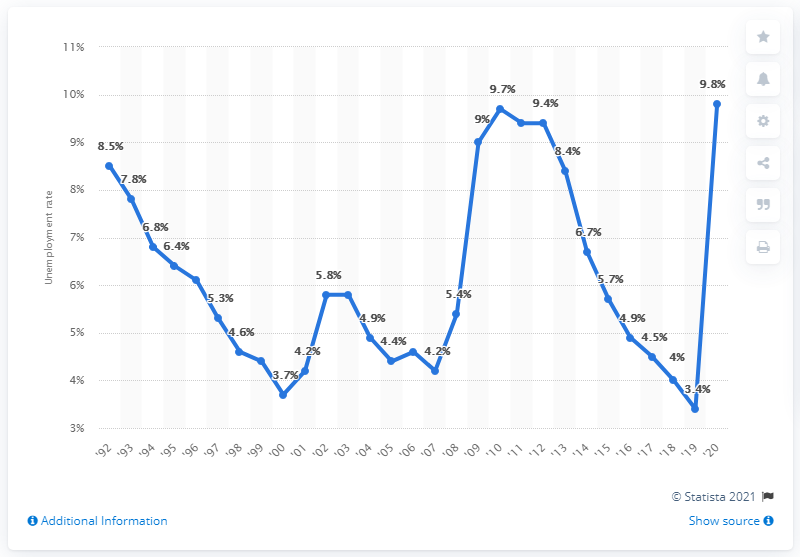Highlight a few significant elements in this photo. According to the previous year's data, the unemployment rate in New Jersey was 3.4%. In the year 2020, the unemployment rate in New Jersey was 9.8%. 